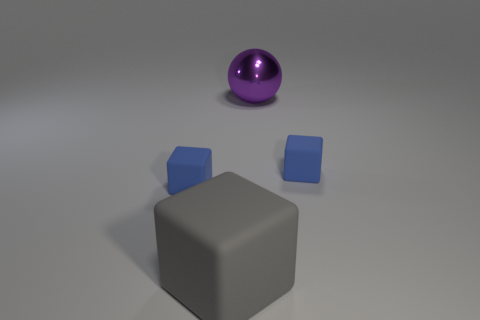Subtract 1 blocks. How many blocks are left? 2 Add 3 purple metallic objects. How many objects exist? 7 Subtract all spheres. How many objects are left? 3 Subtract 0 red cubes. How many objects are left? 4 Subtract all large rubber objects. Subtract all small cubes. How many objects are left? 1 Add 2 blue cubes. How many blue cubes are left? 4 Add 2 gray rubber spheres. How many gray rubber spheres exist? 2 